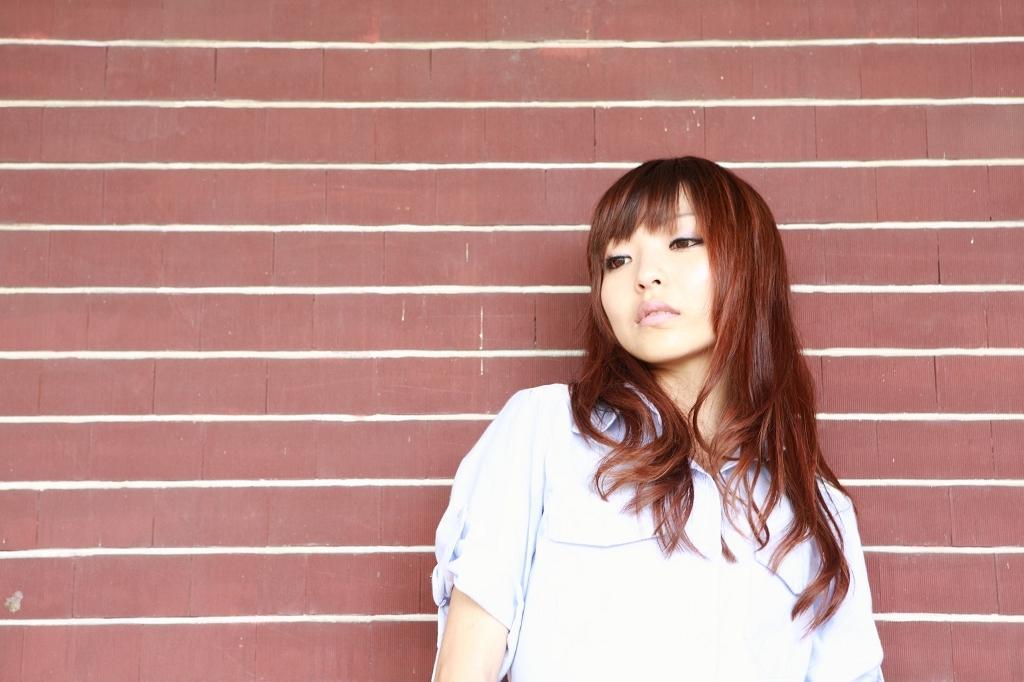In one or two sentences, can you explain what this image depicts? In this image there is a woman wearing a shirt. Behind her there is a wall. 